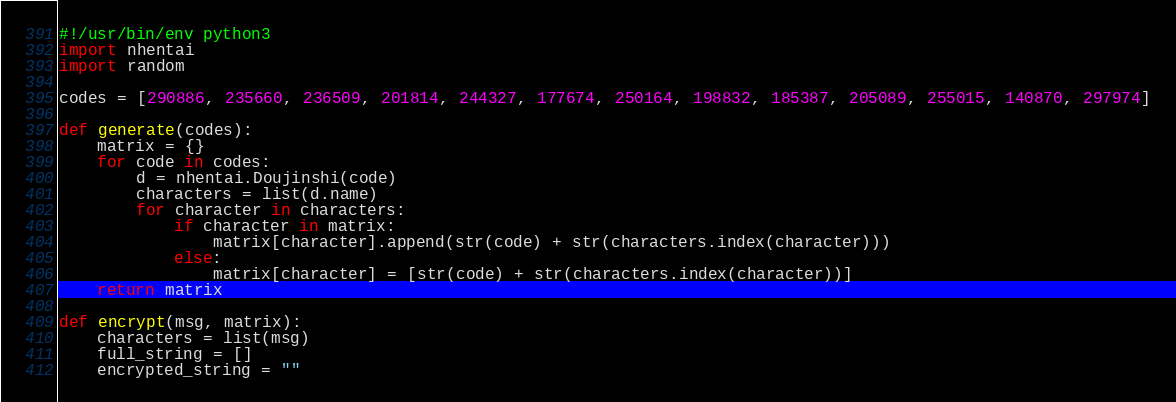Convert code to text. <code><loc_0><loc_0><loc_500><loc_500><_Python_>#!/usr/bin/env python3
import nhentai
import random

codes = [290886, 235660, 236509, 201814, 244327, 177674, 250164, 198832, 185387, 205089, 255015, 140870, 297974]

def generate(codes):
    matrix = {}
    for code in codes:
        d = nhentai.Doujinshi(code)
        characters = list(d.name)
        for character in characters:
            if character in matrix:
                matrix[character].append(str(code) + str(characters.index(character)))
            else:
                matrix[character] = [str(code) + str(characters.index(character))]
    return matrix

def encrypt(msg, matrix):
    characters = list(msg)
    full_string = []
    encrypted_string = ""</code> 